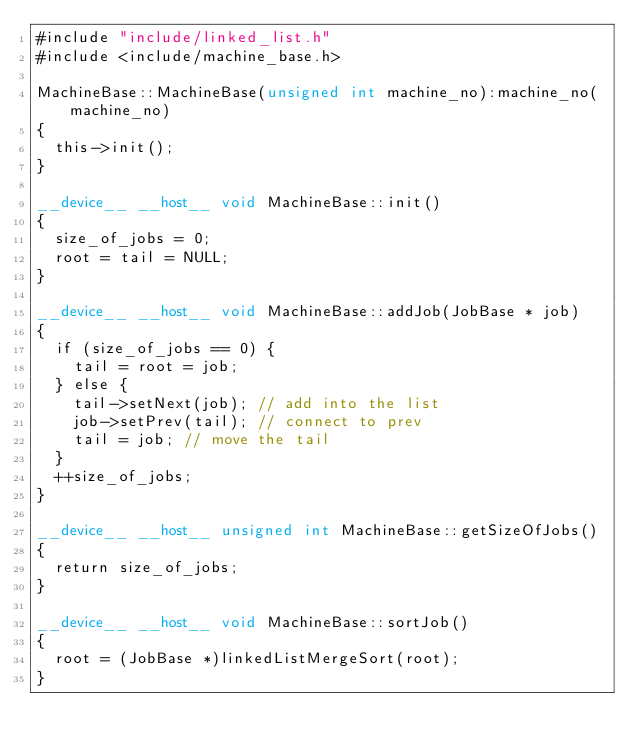<code> <loc_0><loc_0><loc_500><loc_500><_Cuda_>#include "include/linked_list.h"
#include <include/machine_base.h>

MachineBase::MachineBase(unsigned int machine_no):machine_no(machine_no)
{
	this->init();
}

__device__ __host__ void MachineBase::init()
{
	size_of_jobs = 0;
	root = tail = NULL;
}

__device__ __host__ void MachineBase::addJob(JobBase * job)
{
	if (size_of_jobs == 0) {
		tail = root = job;	
	} else {
		tail->setNext(job); // add into the list
		job->setPrev(tail); // connect to prev
		tail = job;	// move the tail
	}
	++size_of_jobs;
}

__device__ __host__ unsigned int MachineBase::getSizeOfJobs()
{
	return size_of_jobs;
}

__device__ __host__ void MachineBase::sortJob()
{
	root = (JobBase *)linkedListMergeSort(root);
}

</code> 